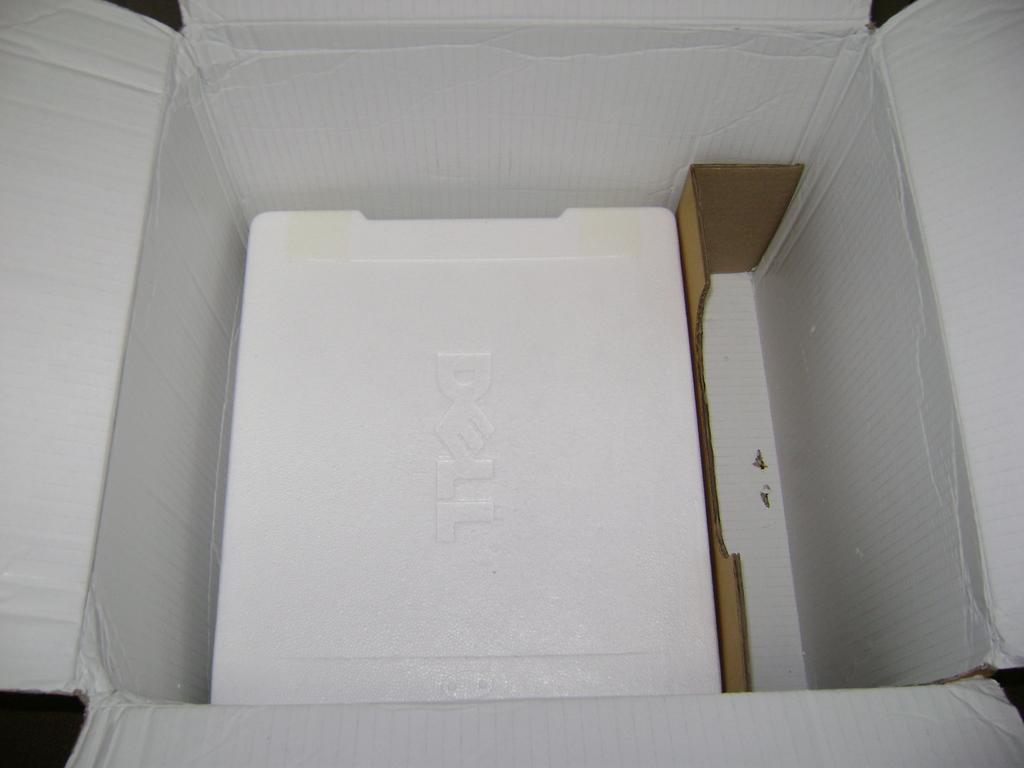<image>
Describe the image concisely. An open box containing Styrofoambox of a Dell product 